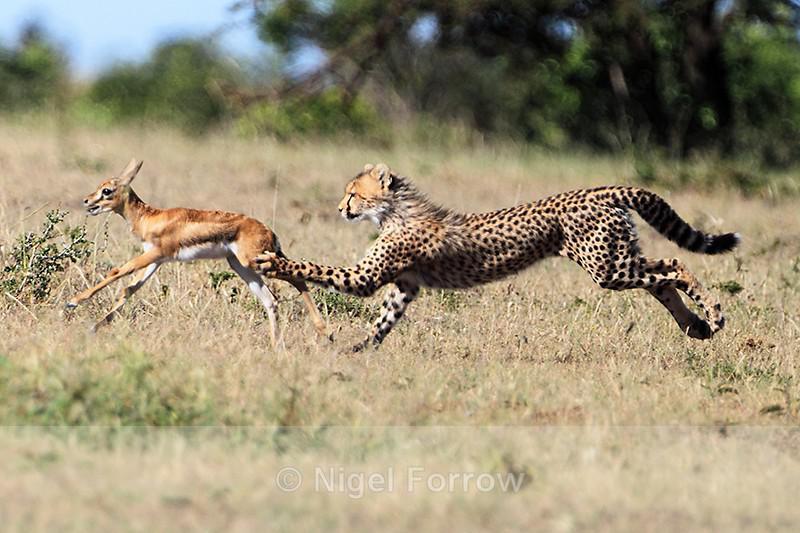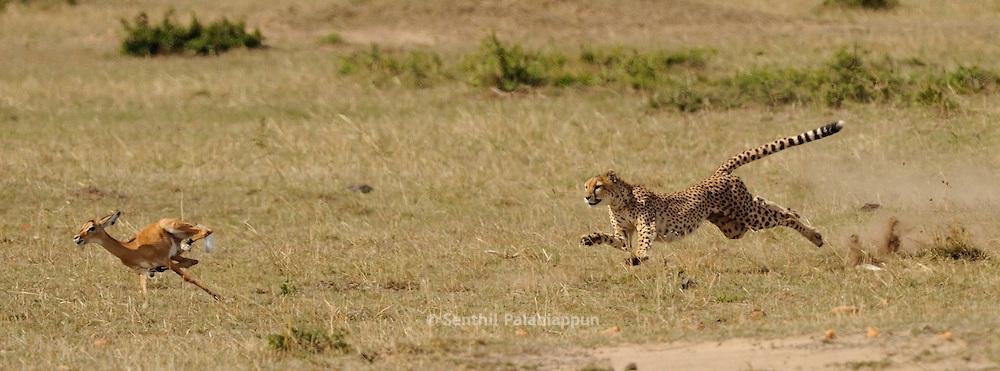The first image is the image on the left, the second image is the image on the right. Analyze the images presented: Is the assertion "A single cheetah is chasing after a single prey in each image." valid? Answer yes or no. Yes. The first image is the image on the left, the second image is the image on the right. Considering the images on both sides, is "All cheetahs appear to be actively chasing adult gazelles." valid? Answer yes or no. Yes. 